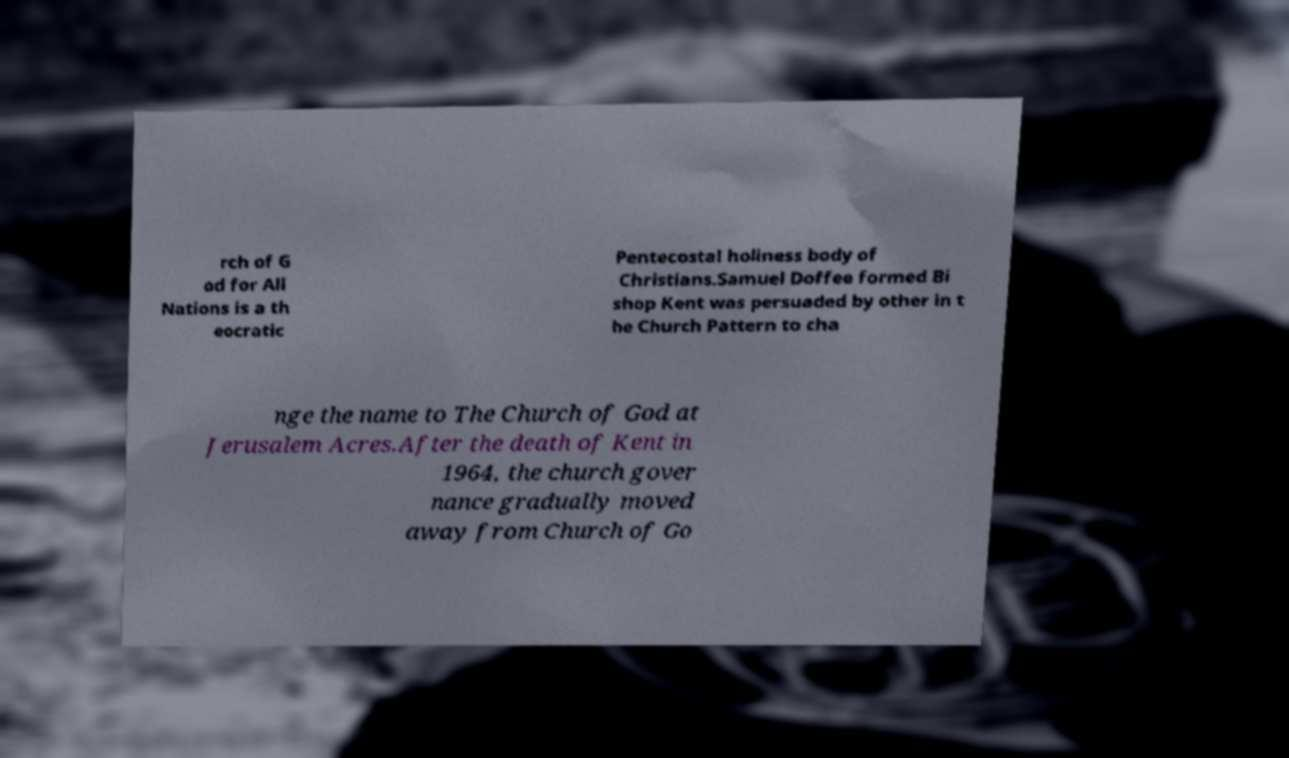Please read and relay the text visible in this image. What does it say? rch of G od for All Nations is a th eocratic Pentecostal holiness body of Christians.Samuel Doffee formed Bi shop Kent was persuaded by other in t he Church Pattern to cha nge the name to The Church of God at Jerusalem Acres.After the death of Kent in 1964, the church gover nance gradually moved away from Church of Go 